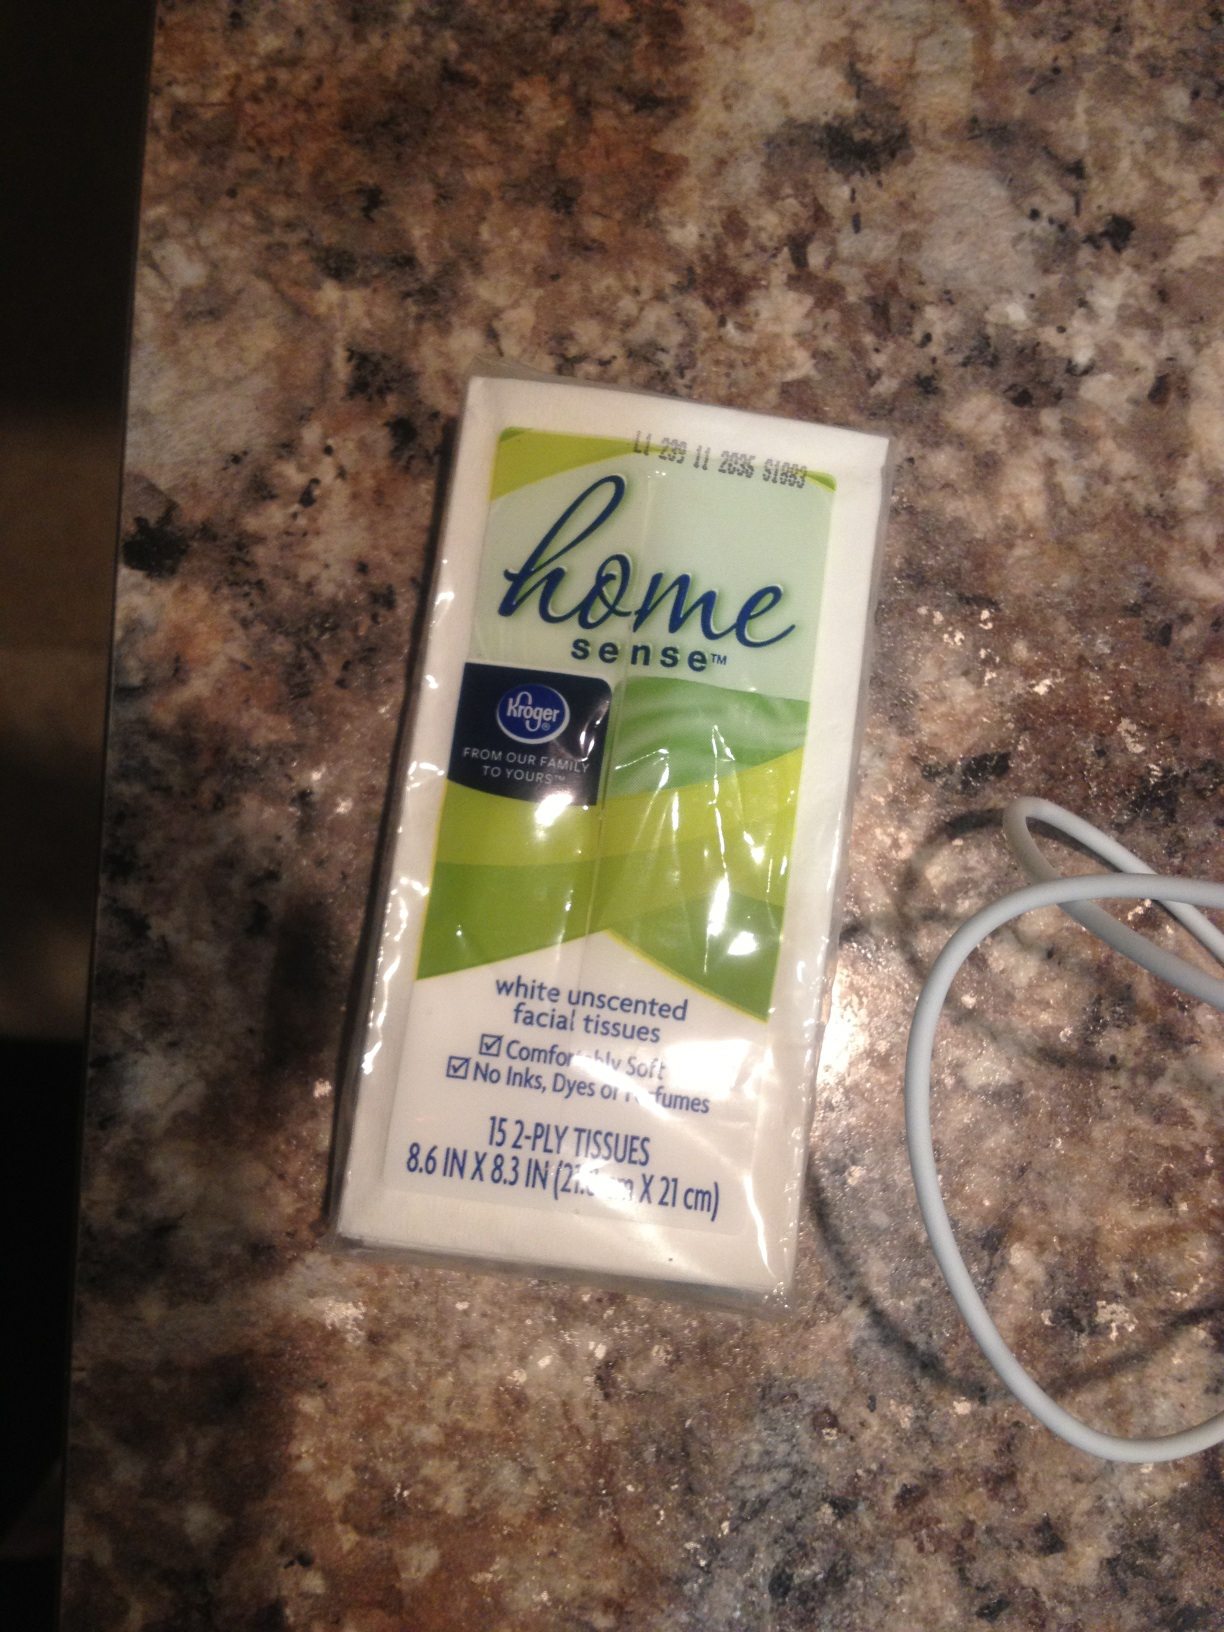Can you tell me more about the usability of this product? This pack of Home Sense white unscented facial tissues is quite versatile. It contains 15 2-ply tissues, making it lightweight and easy to carry. It's perfect for use in quick clean-ups, for wiping hands or face, and is gentle on the skin due to its comfortsoft texture. Its compact size makes it convenient to keep in your bag, car, or desk. What are the dimensions mentioned on the packet? The dimensions of the tissues are noted as 8.6 inches by 8.3 inches (21.8 cm x 21 cm) on the packet. These dimensions indicate that each tissue is of a standard size, suitable for a variety of uses. 